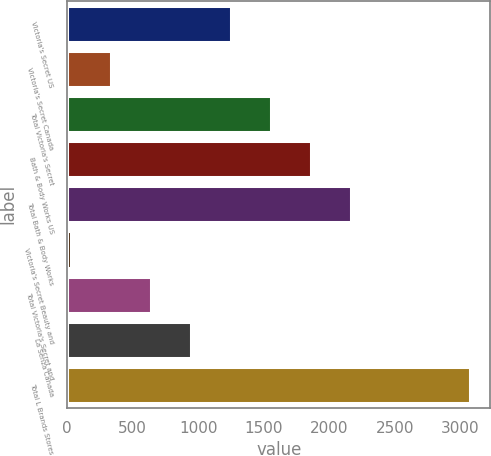Convert chart. <chart><loc_0><loc_0><loc_500><loc_500><bar_chart><fcel>Victoria's Secret US<fcel>Victoria's Secret Canada<fcel>Total Victoria's Secret<fcel>Bath & Body Works US<fcel>Total Bath & Body Works<fcel>Victoria's Secret Beauty and<fcel>Total Victoria's Secret and<fcel>La Senza Canada<fcel>Total L Brands Stores<nl><fcel>1248.2<fcel>335.3<fcel>1552.5<fcel>1856.8<fcel>2161.1<fcel>31<fcel>639.6<fcel>943.9<fcel>3074<nl></chart> 